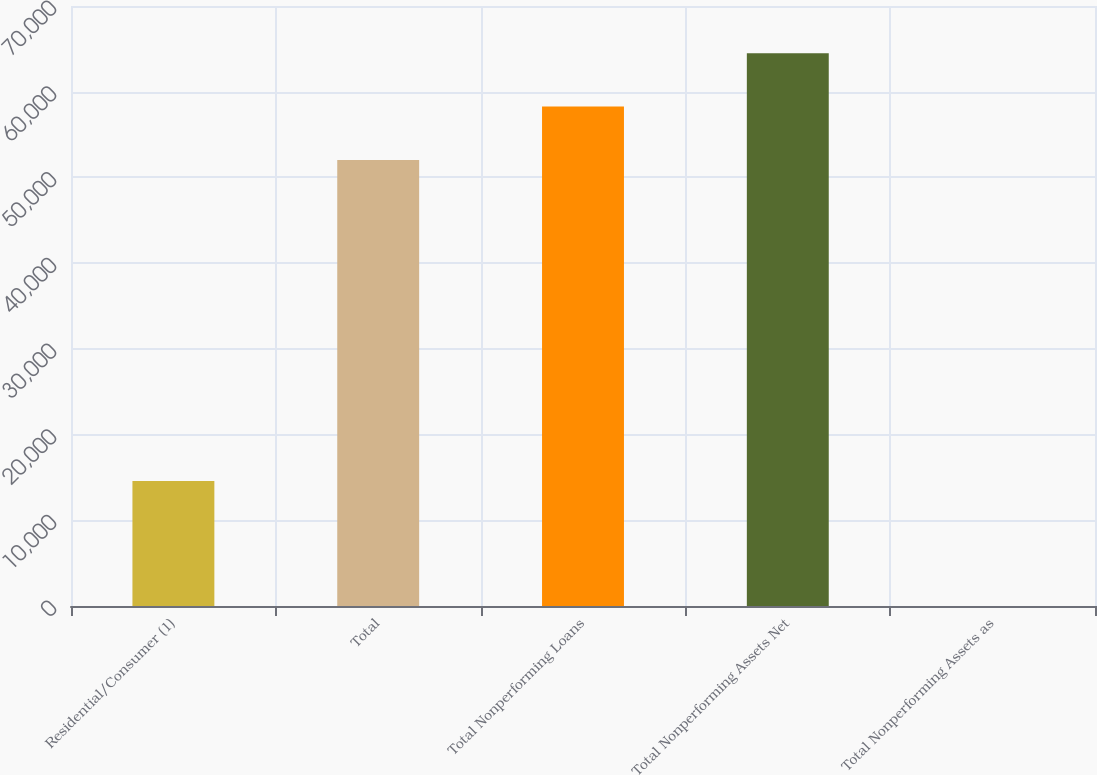Convert chart to OTSL. <chart><loc_0><loc_0><loc_500><loc_500><bar_chart><fcel>Residential/Consumer (1)<fcel>Total<fcel>Total Nonperforming Loans<fcel>Total Nonperforming Assets Net<fcel>Total Nonperforming Assets as<nl><fcel>14571<fcel>52033<fcel>58263.7<fcel>64494.4<fcel>0.88<nl></chart> 